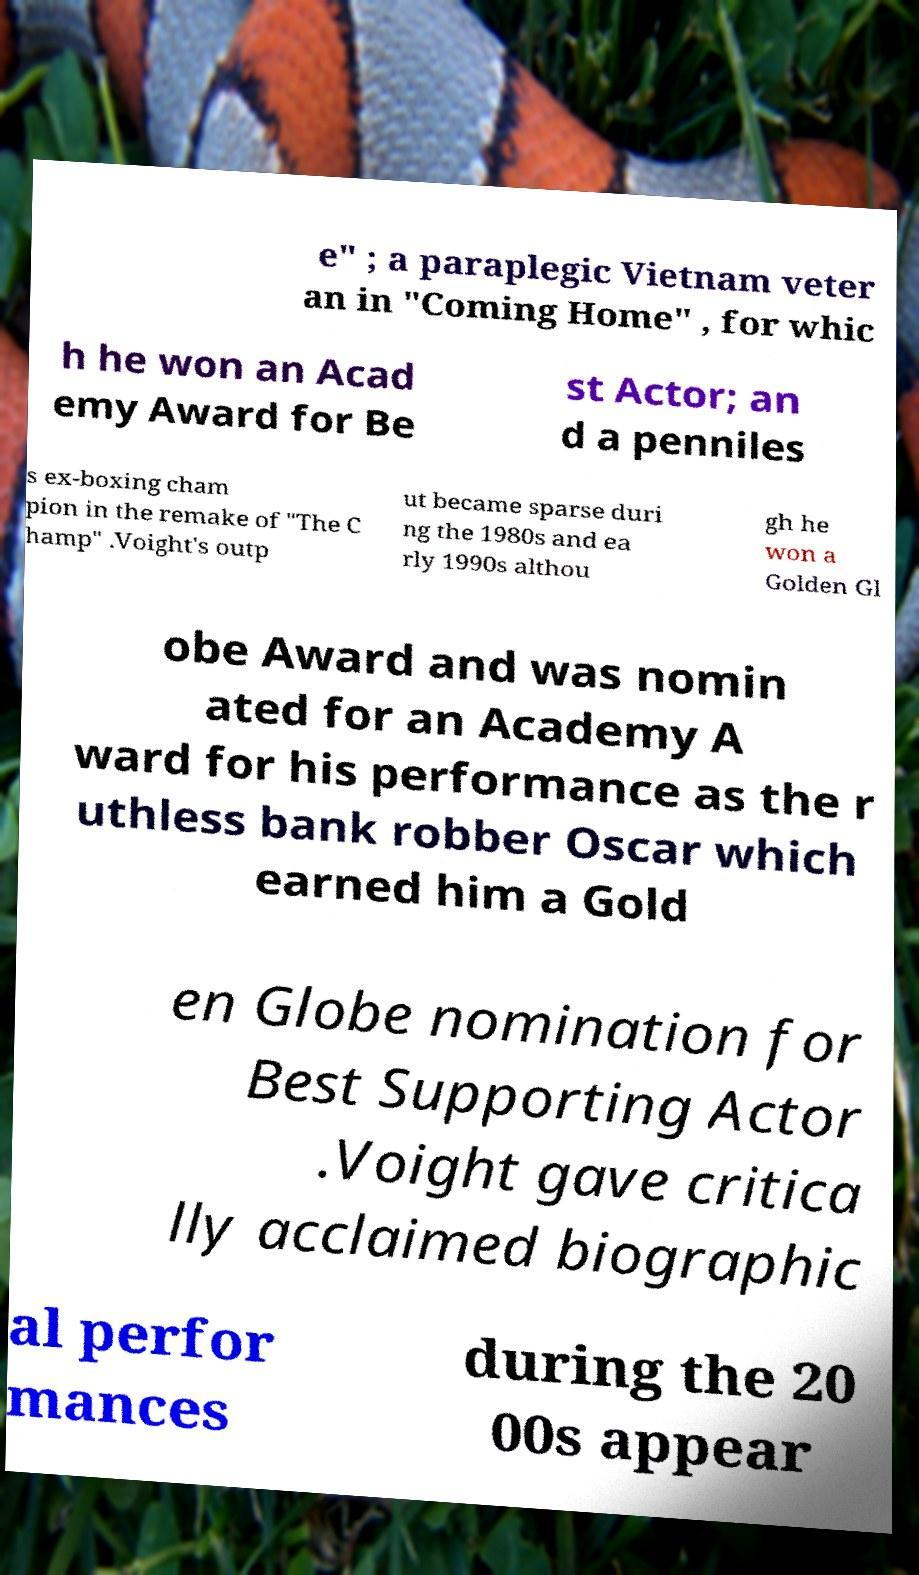I need the written content from this picture converted into text. Can you do that? e" ; a paraplegic Vietnam veter an in "Coming Home" , for whic h he won an Acad emy Award for Be st Actor; an d a penniles s ex-boxing cham pion in the remake of "The C hamp" .Voight's outp ut became sparse duri ng the 1980s and ea rly 1990s althou gh he won a Golden Gl obe Award and was nomin ated for an Academy A ward for his performance as the r uthless bank robber Oscar which earned him a Gold en Globe nomination for Best Supporting Actor .Voight gave critica lly acclaimed biographic al perfor mances during the 20 00s appear 